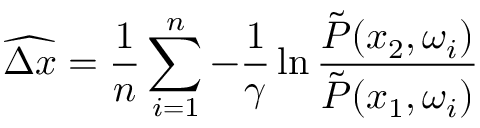Convert formula to latex. <formula><loc_0><loc_0><loc_500><loc_500>\widehat { \Delta x } = \frac { 1 } { n } \sum _ { i = 1 } ^ { n } - \frac { 1 } { \gamma } \ln \frac { \tilde { P } ( x _ { 2 } , \omega _ { i } ) } { \tilde { P } ( x _ { 1 } , \omega _ { i } ) }</formula> 